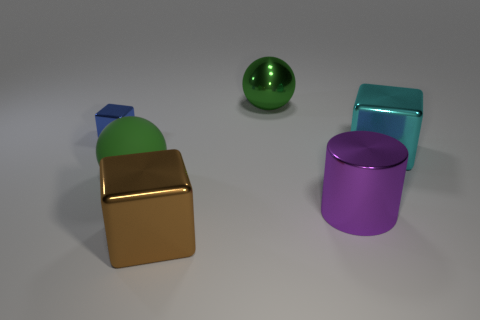Add 1 small green matte blocks. How many objects exist? 7 Subtract all spheres. How many objects are left? 4 Subtract 0 yellow balls. How many objects are left? 6 Subtract all brown things. Subtract all green metallic things. How many objects are left? 4 Add 2 blue objects. How many blue objects are left? 3 Add 3 large green spheres. How many large green spheres exist? 5 